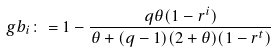<formula> <loc_0><loc_0><loc_500><loc_500>\ g b _ { i } \colon = 1 - \frac { q \theta ( 1 - r ^ { i } ) } { \theta + ( q - 1 ) ( 2 + \theta ) ( 1 - r ^ { t } ) }</formula> 